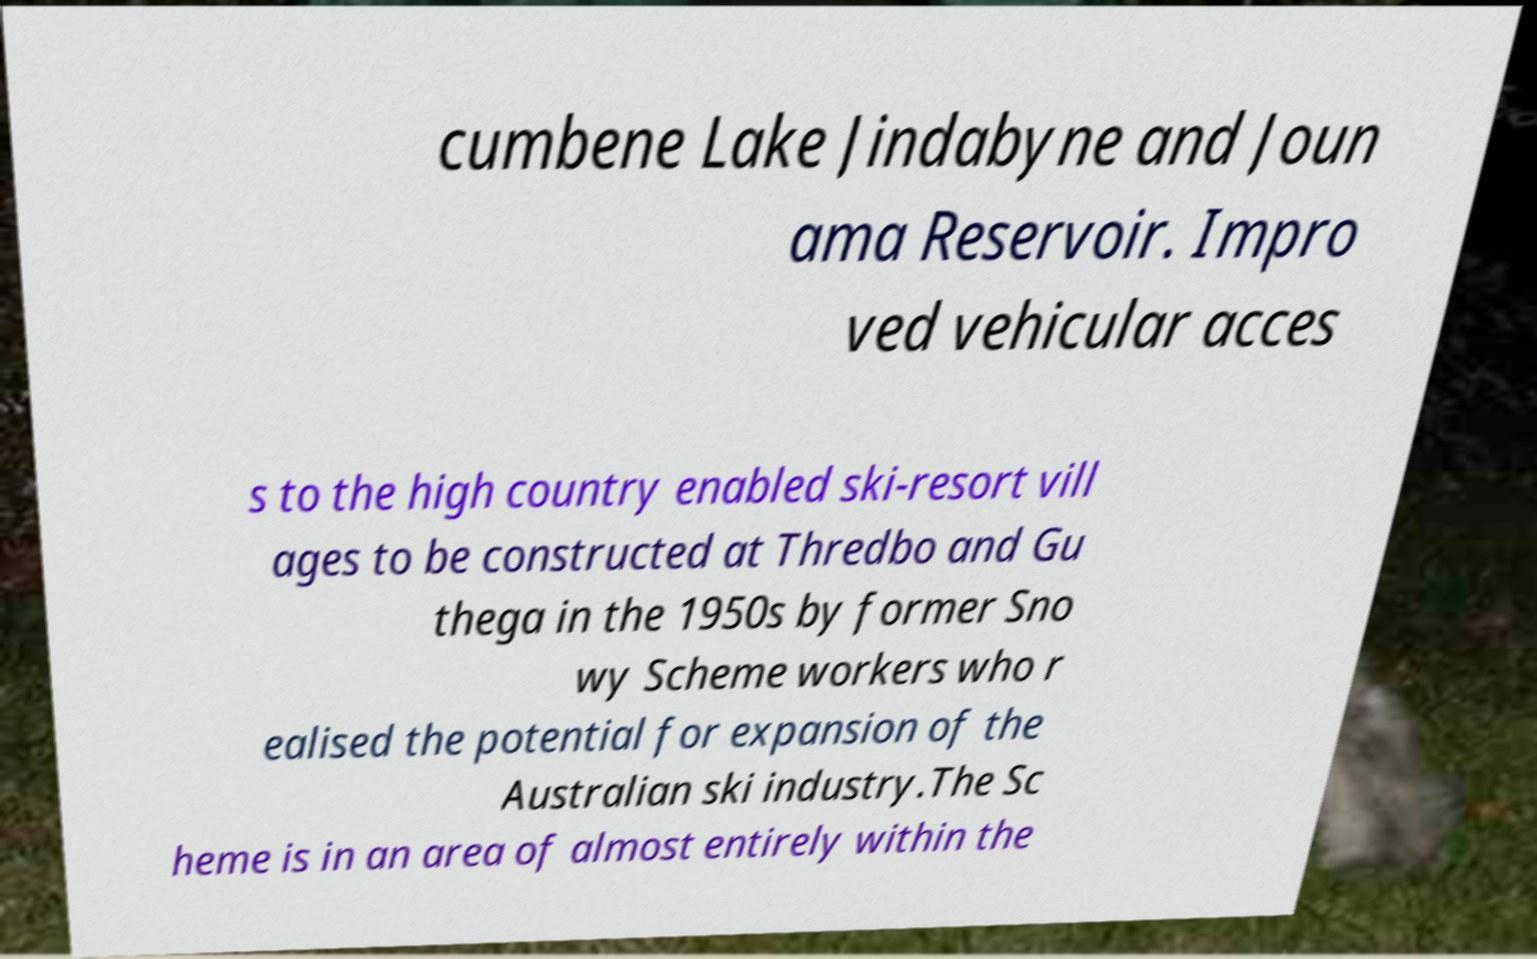What messages or text are displayed in this image? I need them in a readable, typed format. cumbene Lake Jindabyne and Joun ama Reservoir. Impro ved vehicular acces s to the high country enabled ski-resort vill ages to be constructed at Thredbo and Gu thega in the 1950s by former Sno wy Scheme workers who r ealised the potential for expansion of the Australian ski industry.The Sc heme is in an area of almost entirely within the 